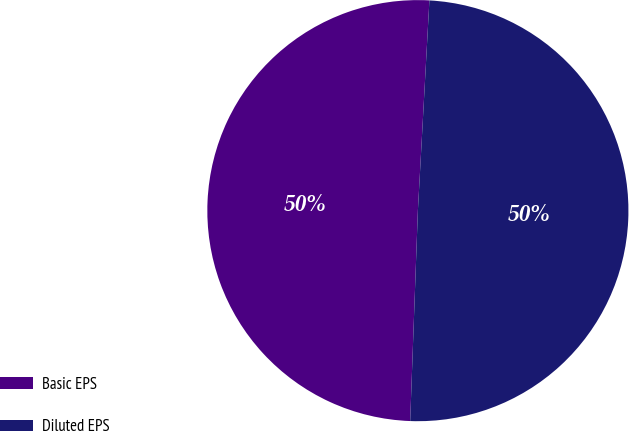Convert chart to OTSL. <chart><loc_0><loc_0><loc_500><loc_500><pie_chart><fcel>Basic EPS<fcel>Diluted EPS<nl><fcel>50.29%<fcel>49.71%<nl></chart> 